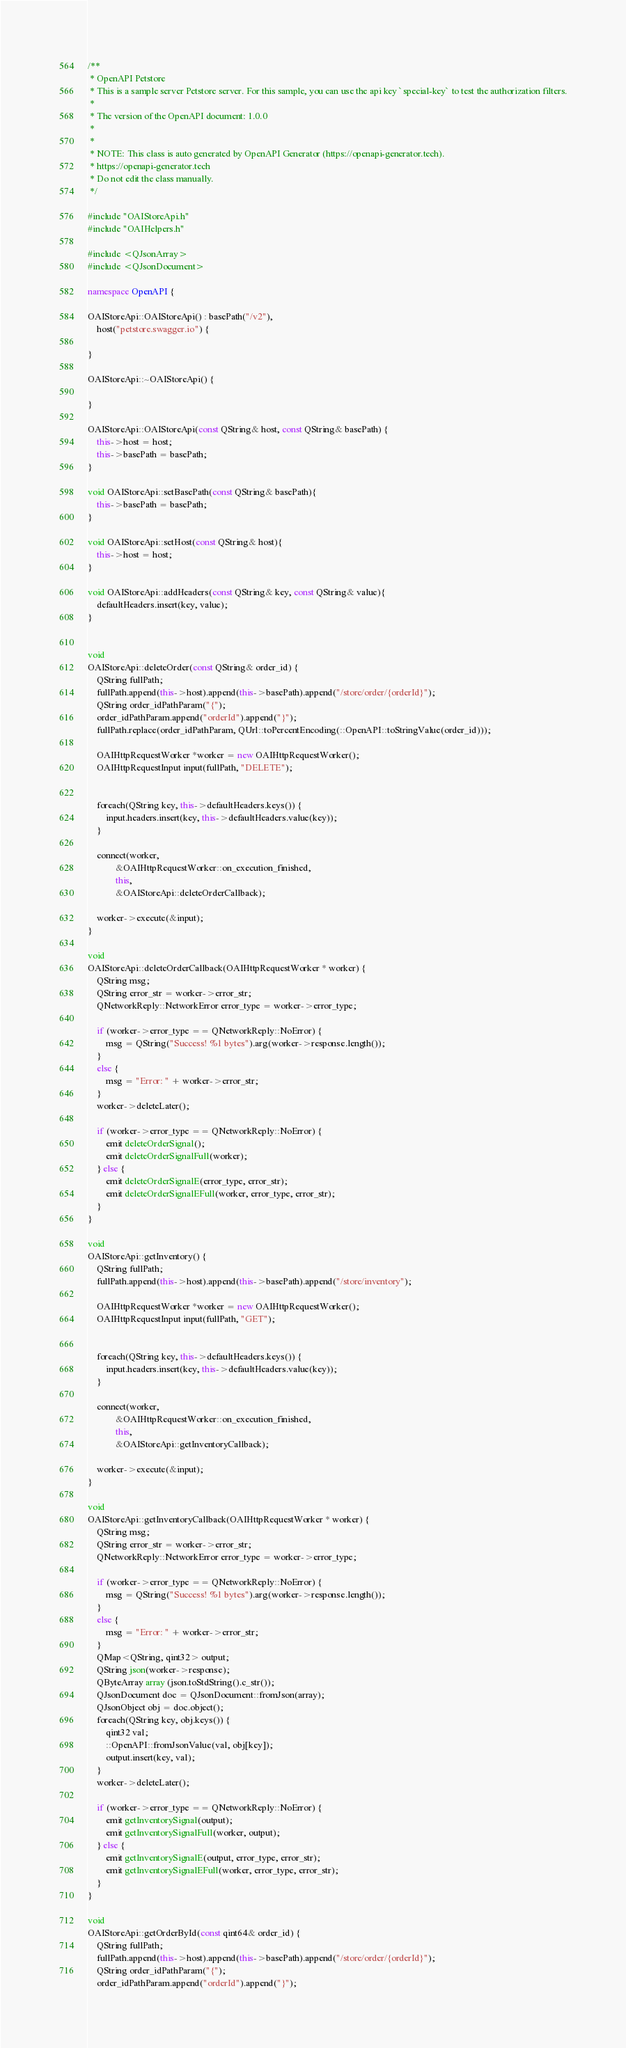Convert code to text. <code><loc_0><loc_0><loc_500><loc_500><_C++_>/**
 * OpenAPI Petstore
 * This is a sample server Petstore server. For this sample, you can use the api key `special-key` to test the authorization filters.
 *
 * The version of the OpenAPI document: 1.0.0
 * 
 *
 * NOTE: This class is auto generated by OpenAPI Generator (https://openapi-generator.tech).
 * https://openapi-generator.tech
 * Do not edit the class manually.
 */

#include "OAIStoreApi.h"
#include "OAIHelpers.h"

#include <QJsonArray>
#include <QJsonDocument>

namespace OpenAPI {

OAIStoreApi::OAIStoreApi() : basePath("/v2"),
    host("petstore.swagger.io") {

}

OAIStoreApi::~OAIStoreApi() {

}

OAIStoreApi::OAIStoreApi(const QString& host, const QString& basePath) {
    this->host = host;
    this->basePath = basePath;
}

void OAIStoreApi::setBasePath(const QString& basePath){
    this->basePath = basePath;
}

void OAIStoreApi::setHost(const QString& host){
    this->host = host;
}

void OAIStoreApi::addHeaders(const QString& key, const QString& value){
    defaultHeaders.insert(key, value);
}


void
OAIStoreApi::deleteOrder(const QString& order_id) {
    QString fullPath;
    fullPath.append(this->host).append(this->basePath).append("/store/order/{orderId}");
    QString order_idPathParam("{"); 
    order_idPathParam.append("orderId").append("}");
    fullPath.replace(order_idPathParam, QUrl::toPercentEncoding(::OpenAPI::toStringValue(order_id)));
    
    OAIHttpRequestWorker *worker = new OAIHttpRequestWorker();
    OAIHttpRequestInput input(fullPath, "DELETE");


    foreach(QString key, this->defaultHeaders.keys()) {
        input.headers.insert(key, this->defaultHeaders.value(key));
    }

    connect(worker,
            &OAIHttpRequestWorker::on_execution_finished,
            this,
            &OAIStoreApi::deleteOrderCallback);

    worker->execute(&input);
}

void
OAIStoreApi::deleteOrderCallback(OAIHttpRequestWorker * worker) {
    QString msg;
    QString error_str = worker->error_str;
    QNetworkReply::NetworkError error_type = worker->error_type;

    if (worker->error_type == QNetworkReply::NoError) {
        msg = QString("Success! %1 bytes").arg(worker->response.length());
    }
    else {
        msg = "Error: " + worker->error_str;
    }
    worker->deleteLater();

    if (worker->error_type == QNetworkReply::NoError) {
        emit deleteOrderSignal();
        emit deleteOrderSignalFull(worker);
    } else {
        emit deleteOrderSignalE(error_type, error_str);
        emit deleteOrderSignalEFull(worker, error_type, error_str);
    }
}

void
OAIStoreApi::getInventory() {
    QString fullPath;
    fullPath.append(this->host).append(this->basePath).append("/store/inventory");
    
    OAIHttpRequestWorker *worker = new OAIHttpRequestWorker();
    OAIHttpRequestInput input(fullPath, "GET");


    foreach(QString key, this->defaultHeaders.keys()) {
        input.headers.insert(key, this->defaultHeaders.value(key));
    }

    connect(worker,
            &OAIHttpRequestWorker::on_execution_finished,
            this,
            &OAIStoreApi::getInventoryCallback);

    worker->execute(&input);
}

void
OAIStoreApi::getInventoryCallback(OAIHttpRequestWorker * worker) {
    QString msg;
    QString error_str = worker->error_str;
    QNetworkReply::NetworkError error_type = worker->error_type;

    if (worker->error_type == QNetworkReply::NoError) {
        msg = QString("Success! %1 bytes").arg(worker->response.length());
    }
    else {
        msg = "Error: " + worker->error_str;
    }
    QMap<QString, qint32> output;
    QString json(worker->response);
    QByteArray array (json.toStdString().c_str());
    QJsonDocument doc = QJsonDocument::fromJson(array);
    QJsonObject obj = doc.object();
    foreach(QString key, obj.keys()) {
        qint32 val;
        ::OpenAPI::fromJsonValue(val, obj[key]);
        output.insert(key, val);
    }
    worker->deleteLater();

    if (worker->error_type == QNetworkReply::NoError) {
        emit getInventorySignal(output);
        emit getInventorySignalFull(worker, output);
    } else {
        emit getInventorySignalE(output, error_type, error_str);
        emit getInventorySignalEFull(worker, error_type, error_str);
    }
}

void
OAIStoreApi::getOrderById(const qint64& order_id) {
    QString fullPath;
    fullPath.append(this->host).append(this->basePath).append("/store/order/{orderId}");
    QString order_idPathParam("{"); 
    order_idPathParam.append("orderId").append("}");</code> 